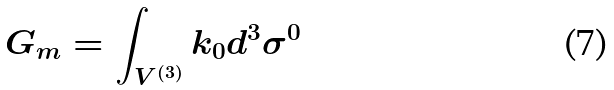<formula> <loc_0><loc_0><loc_500><loc_500>G _ { m } = \int _ { V ^ { ( 3 ) } } k _ { 0 } d ^ { 3 } \sigma ^ { 0 }</formula> 